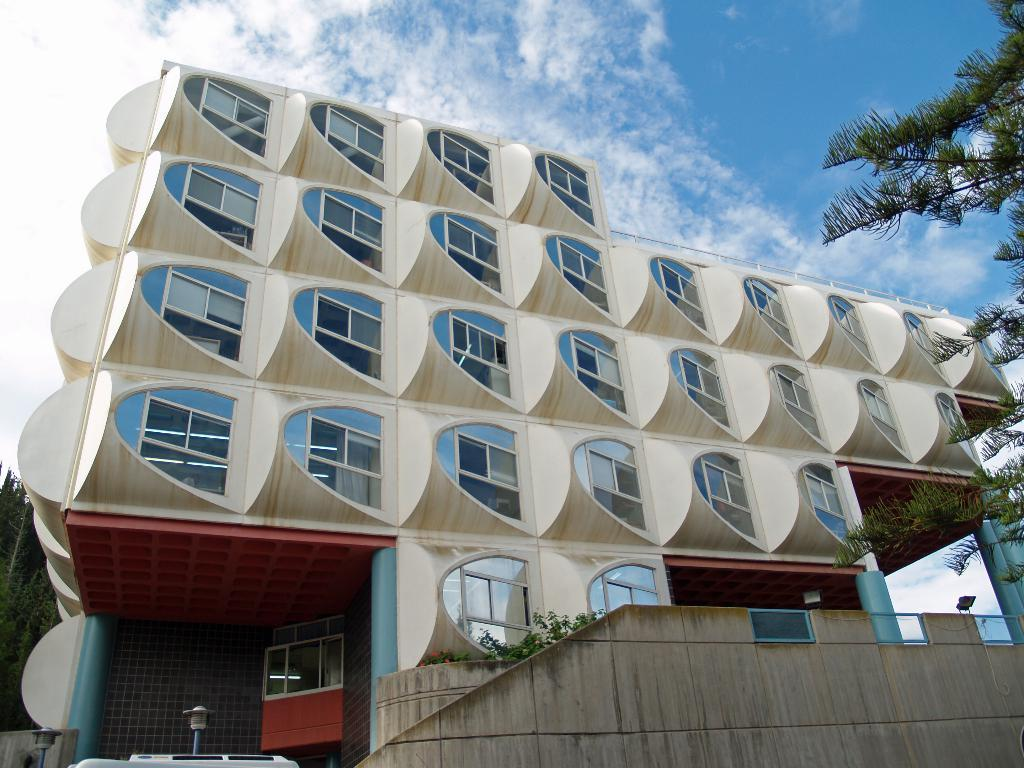What is the condition of the sky in the image? The sky is cloudy in the image. What type of windows does the building have? The building has glass windows. What type of vegetation can be seen in the image? There are trees visible in the image. What structures are present in the image for providing light? Light poles are present in the image. What type of theory is being discussed in the lunchroom in the image? There is no lunchroom present in the image, and therefore no theory can be discussed. Can you tell me how many cooks are visible in the image? There are no cooks visible in the image. 